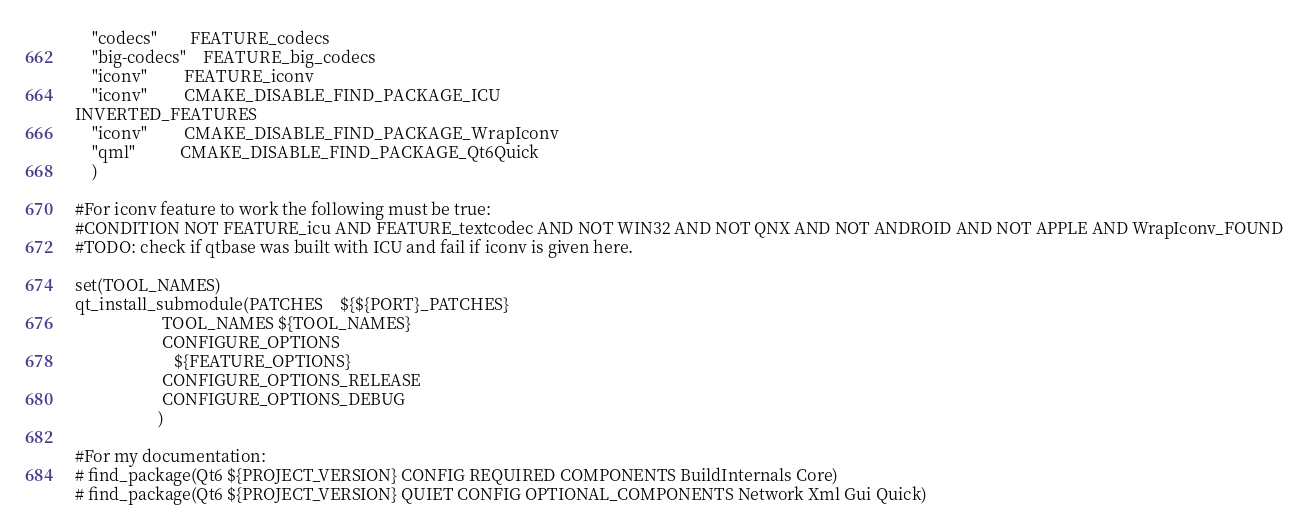<code> <loc_0><loc_0><loc_500><loc_500><_CMake_>    "codecs"        FEATURE_codecs
    "big-codecs"    FEATURE_big_codecs
    "iconv"         FEATURE_iconv
    "iconv"         CMAKE_DISABLE_FIND_PACKAGE_ICU
INVERTED_FEATURES
    "iconv"         CMAKE_DISABLE_FIND_PACKAGE_WrapIconv
    "qml"           CMAKE_DISABLE_FIND_PACKAGE_Qt6Quick
    )

#For iconv feature to work the following must be true:
#CONDITION NOT FEATURE_icu AND FEATURE_textcodec AND NOT WIN32 AND NOT QNX AND NOT ANDROID AND NOT APPLE AND WrapIconv_FOUND
#TODO: check if qtbase was built with ICU and fail if iconv is given here.

set(TOOL_NAMES)
qt_install_submodule(PATCHES    ${${PORT}_PATCHES}
                     TOOL_NAMES ${TOOL_NAMES}
                     CONFIGURE_OPTIONS
                        ${FEATURE_OPTIONS}
                     CONFIGURE_OPTIONS_RELEASE
                     CONFIGURE_OPTIONS_DEBUG
                    )

#For my documentation:
# find_package(Qt6 ${PROJECT_VERSION} CONFIG REQUIRED COMPONENTS BuildInternals Core)
# find_package(Qt6 ${PROJECT_VERSION} QUIET CONFIG OPTIONAL_COMPONENTS Network Xml Gui Quick)
</code> 